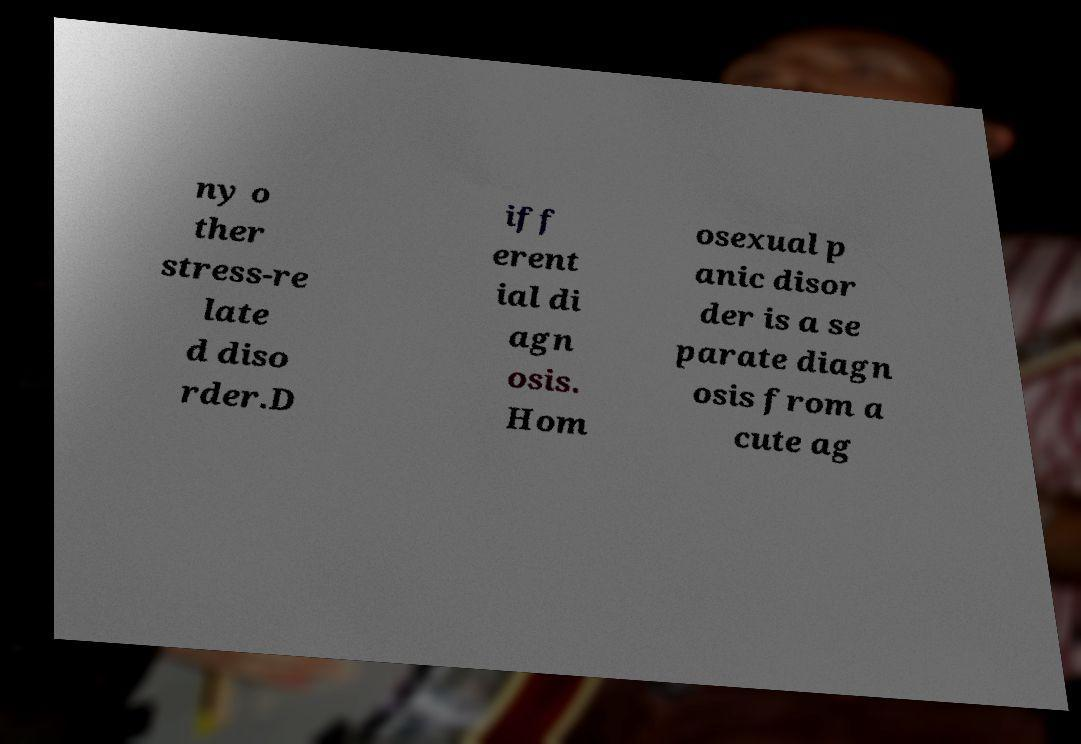Can you accurately transcribe the text from the provided image for me? ny o ther stress-re late d diso rder.D iff erent ial di agn osis. Hom osexual p anic disor der is a se parate diagn osis from a cute ag 